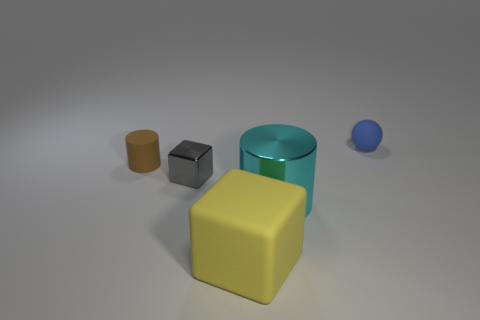What size is the blue sphere that is made of the same material as the big cube?
Your response must be concise. Small. Is there a metal object that has the same color as the rubber cylinder?
Offer a terse response. No. How many objects are tiny blue rubber things that are behind the small gray shiny object or tiny purple cylinders?
Your answer should be very brief. 1. Does the small gray block have the same material as the large object that is behind the yellow matte cube?
Provide a short and direct response. Yes. Is there a blue sphere that has the same material as the cyan thing?
Your answer should be compact. No. How many objects are either rubber cylinders to the left of the sphere or tiny things that are on the left side of the blue ball?
Offer a very short reply. 2. Do the big matte object and the matte object left of the tiny gray shiny block have the same shape?
Give a very brief answer. No. How many other things are there of the same shape as the tiny blue matte object?
Offer a very short reply. 0. What number of objects are either large metal objects or large blue balls?
Your answer should be very brief. 1. Do the matte cylinder and the big metal cylinder have the same color?
Ensure brevity in your answer.  No. 